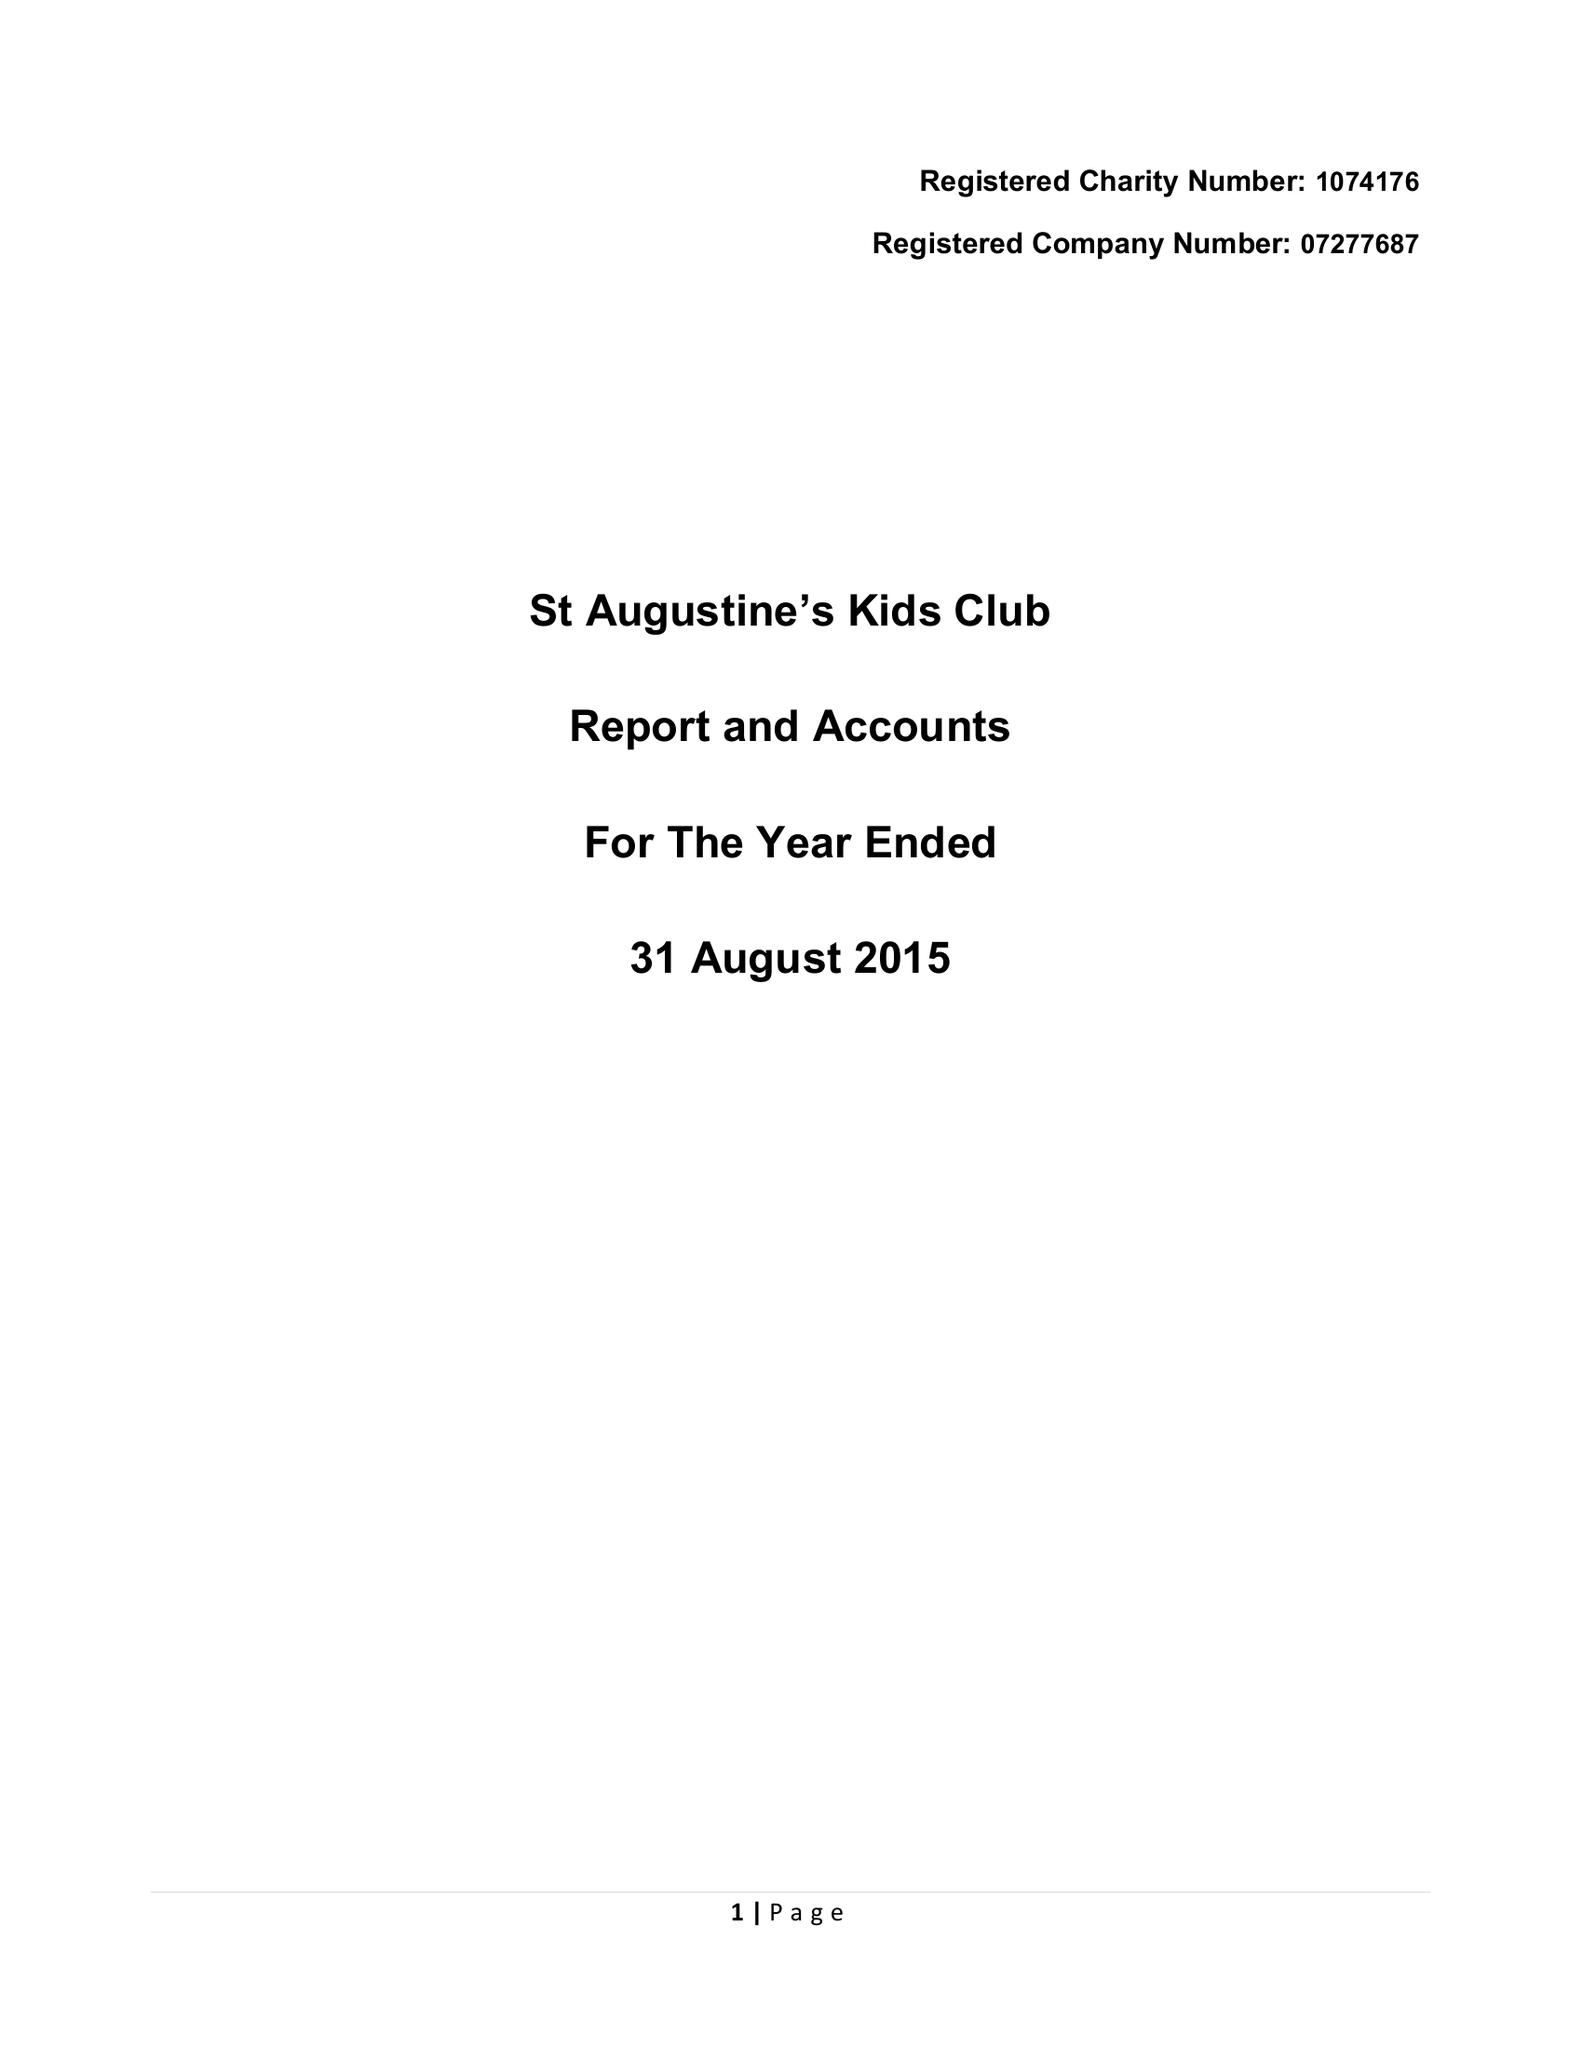What is the value for the report_date?
Answer the question using a single word or phrase. 2015-08-31 